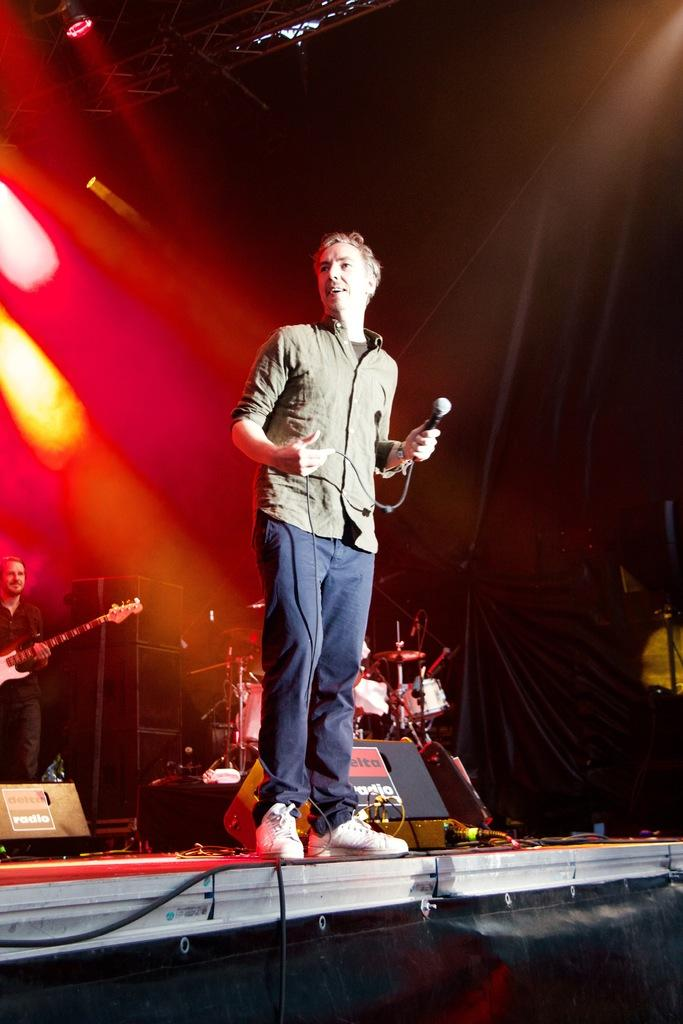What is the person on the left side of the image holding? The person on the left side of the image is holding a microphone. What is the person on the right side of the image holding? The person on the right side of the image is holding a guitar. Can you see a giraffe in the image? No, there is no giraffe present in the image. Is the person holding the microphone on fire in the image? No, there is no indication of fire or burning in the image. 